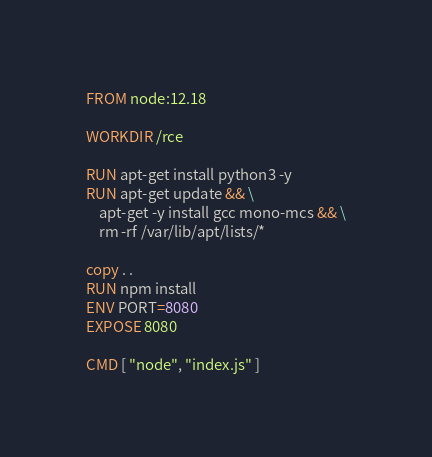<code> <loc_0><loc_0><loc_500><loc_500><_Dockerfile_>FROM node:12.18

WORKDIR /rce

RUN apt-get install python3 -y
RUN apt-get update && \
    apt-get -y install gcc mono-mcs && \
    rm -rf /var/lib/apt/lists/*

copy . .
RUN npm install
ENV PORT=8080
EXPOSE 8080

CMD [ "node", "index.js" ]</code> 